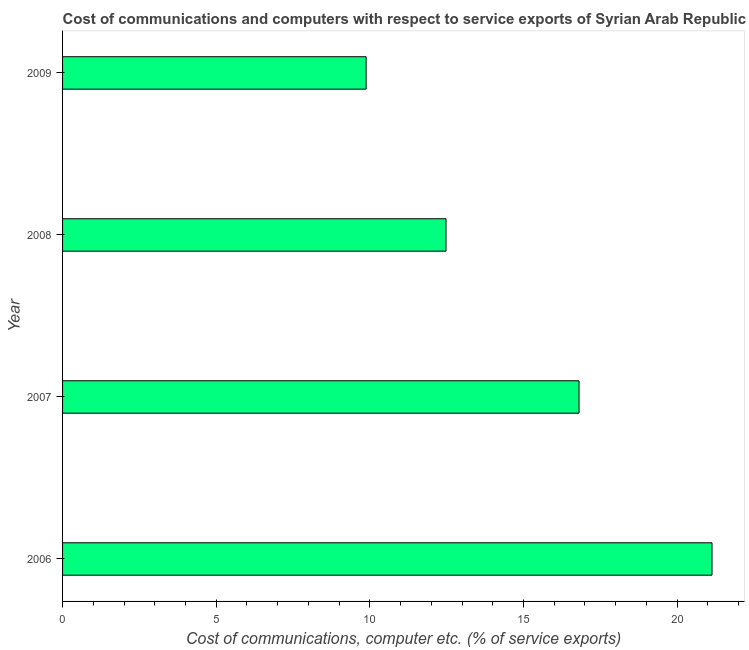What is the title of the graph?
Make the answer very short. Cost of communications and computers with respect to service exports of Syrian Arab Republic. What is the label or title of the X-axis?
Keep it short and to the point. Cost of communications, computer etc. (% of service exports). What is the label or title of the Y-axis?
Your response must be concise. Year. What is the cost of communications and computer in 2009?
Give a very brief answer. 9.88. Across all years, what is the maximum cost of communications and computer?
Provide a succinct answer. 21.14. Across all years, what is the minimum cost of communications and computer?
Ensure brevity in your answer.  9.88. What is the sum of the cost of communications and computer?
Keep it short and to the point. 60.3. What is the difference between the cost of communications and computer in 2006 and 2007?
Give a very brief answer. 4.33. What is the average cost of communications and computer per year?
Ensure brevity in your answer.  15.07. What is the median cost of communications and computer?
Offer a very short reply. 14.64. What is the ratio of the cost of communications and computer in 2006 to that in 2008?
Keep it short and to the point. 1.69. Is the difference between the cost of communications and computer in 2006 and 2007 greater than the difference between any two years?
Provide a succinct answer. No. What is the difference between the highest and the second highest cost of communications and computer?
Give a very brief answer. 4.33. Is the sum of the cost of communications and computer in 2006 and 2009 greater than the maximum cost of communications and computer across all years?
Your answer should be very brief. Yes. What is the difference between the highest and the lowest cost of communications and computer?
Provide a succinct answer. 11.26. Are all the bars in the graph horizontal?
Keep it short and to the point. Yes. How many years are there in the graph?
Your answer should be compact. 4. What is the difference between two consecutive major ticks on the X-axis?
Keep it short and to the point. 5. What is the Cost of communications, computer etc. (% of service exports) of 2006?
Offer a very short reply. 21.14. What is the Cost of communications, computer etc. (% of service exports) in 2007?
Make the answer very short. 16.81. What is the Cost of communications, computer etc. (% of service exports) of 2008?
Your answer should be compact. 12.48. What is the Cost of communications, computer etc. (% of service exports) in 2009?
Make the answer very short. 9.88. What is the difference between the Cost of communications, computer etc. (% of service exports) in 2006 and 2007?
Give a very brief answer. 4.33. What is the difference between the Cost of communications, computer etc. (% of service exports) in 2006 and 2008?
Your answer should be very brief. 8.66. What is the difference between the Cost of communications, computer etc. (% of service exports) in 2006 and 2009?
Give a very brief answer. 11.26. What is the difference between the Cost of communications, computer etc. (% of service exports) in 2007 and 2008?
Ensure brevity in your answer.  4.33. What is the difference between the Cost of communications, computer etc. (% of service exports) in 2007 and 2009?
Your answer should be compact. 6.93. What is the difference between the Cost of communications, computer etc. (% of service exports) in 2008 and 2009?
Give a very brief answer. 2.6. What is the ratio of the Cost of communications, computer etc. (% of service exports) in 2006 to that in 2007?
Offer a very short reply. 1.26. What is the ratio of the Cost of communications, computer etc. (% of service exports) in 2006 to that in 2008?
Offer a very short reply. 1.69. What is the ratio of the Cost of communications, computer etc. (% of service exports) in 2006 to that in 2009?
Provide a short and direct response. 2.14. What is the ratio of the Cost of communications, computer etc. (% of service exports) in 2007 to that in 2008?
Provide a succinct answer. 1.35. What is the ratio of the Cost of communications, computer etc. (% of service exports) in 2007 to that in 2009?
Ensure brevity in your answer.  1.7. What is the ratio of the Cost of communications, computer etc. (% of service exports) in 2008 to that in 2009?
Provide a succinct answer. 1.26. 